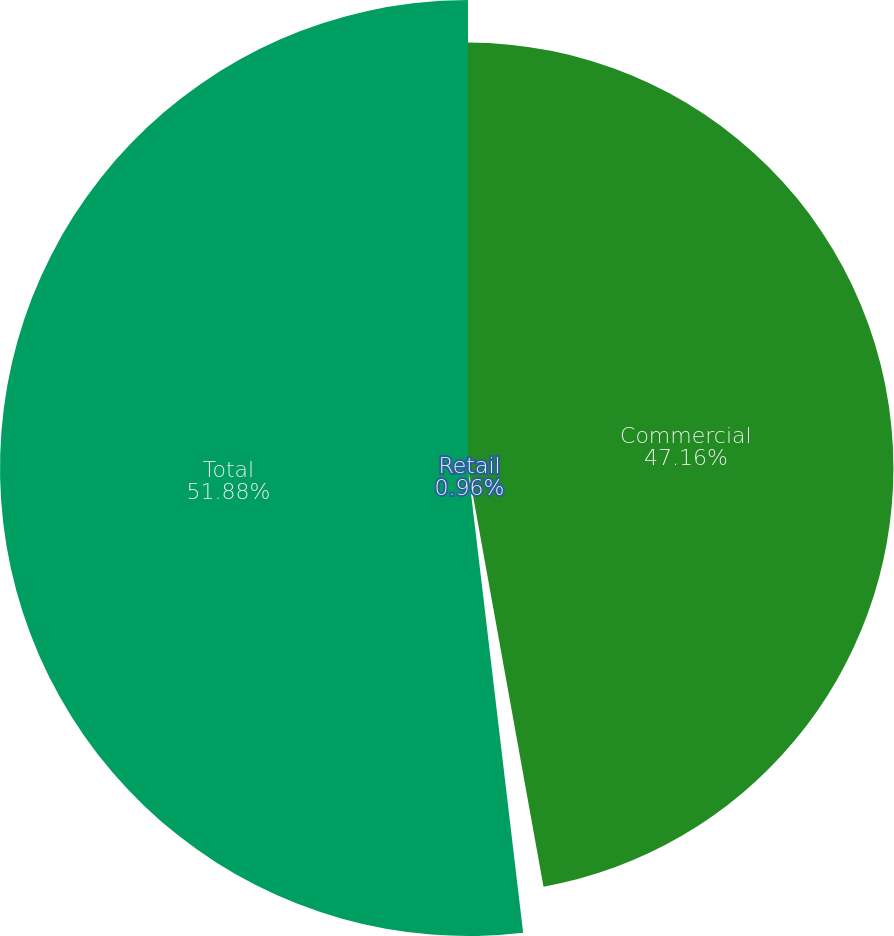<chart> <loc_0><loc_0><loc_500><loc_500><pie_chart><fcel>Commercial<fcel>Retail<fcel>Total<nl><fcel>47.16%<fcel>0.96%<fcel>51.88%<nl></chart> 